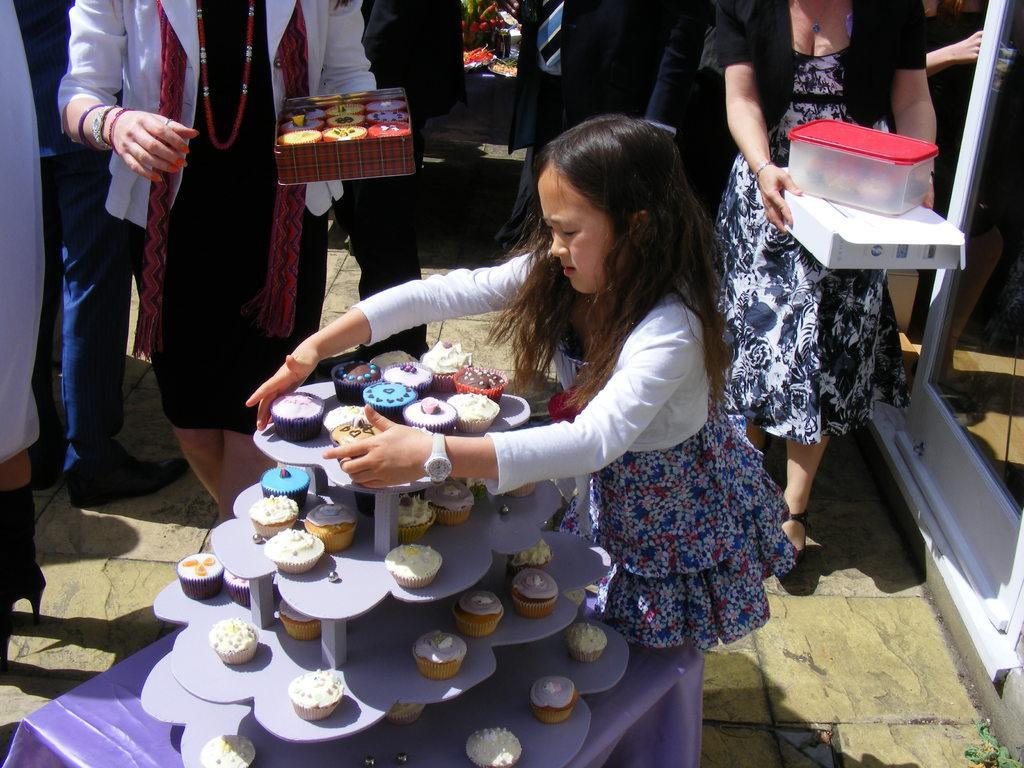Describe this image in one or two sentences. In the picture I can see a girl standing here and here I can see cupcakes are placed on the table. In the background, I can see a few more people standing. 